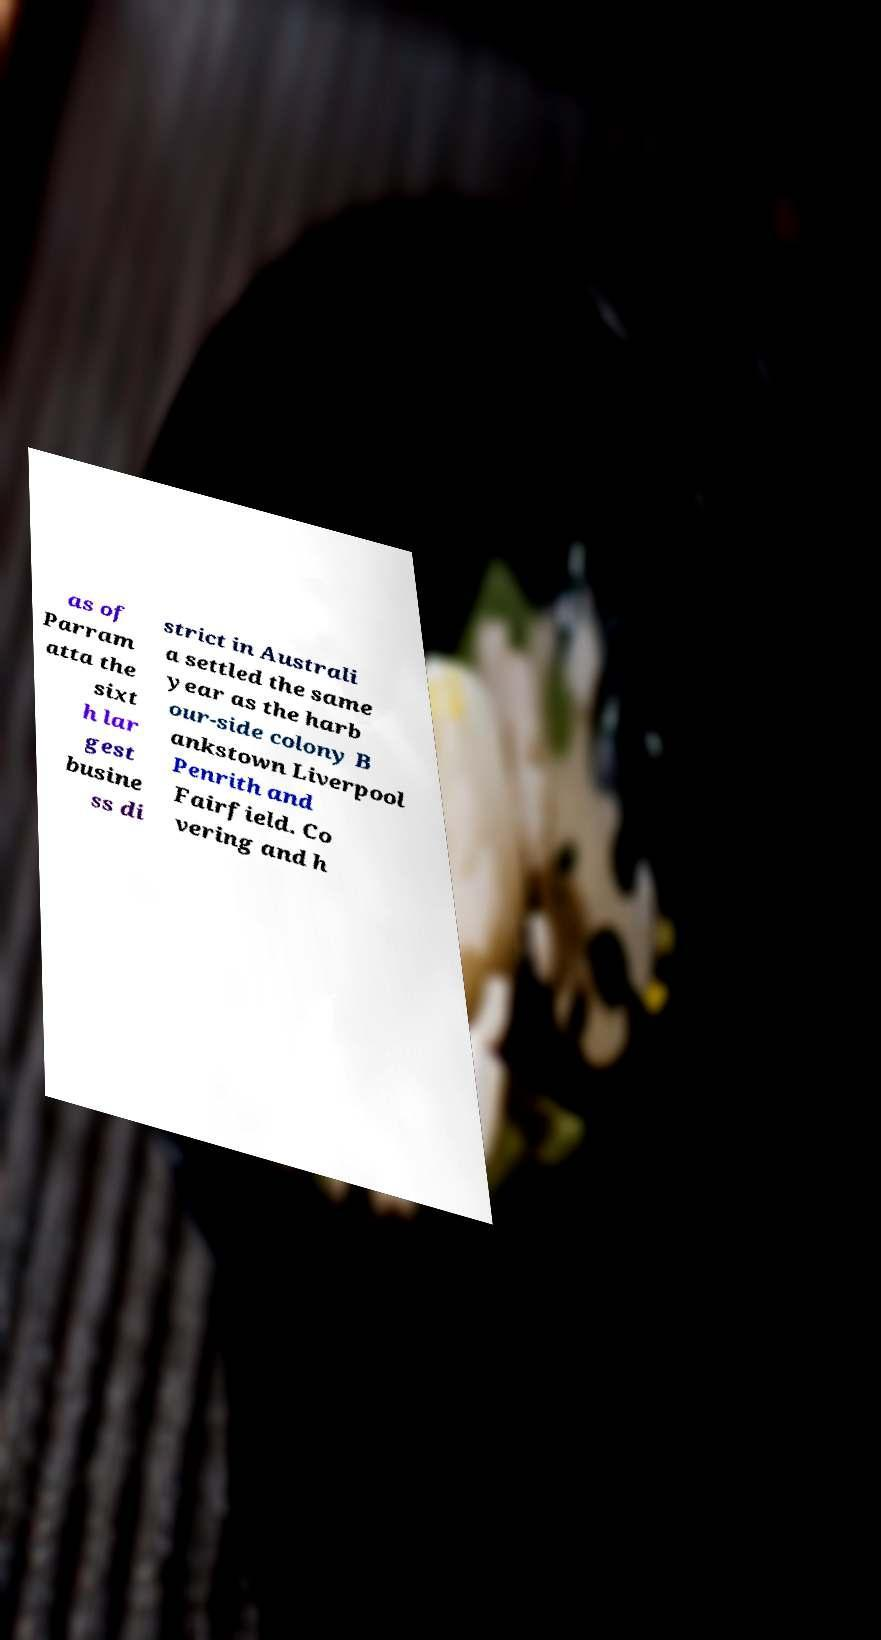Could you assist in decoding the text presented in this image and type it out clearly? as of Parram atta the sixt h lar gest busine ss di strict in Australi a settled the same year as the harb our-side colony B ankstown Liverpool Penrith and Fairfield. Co vering and h 